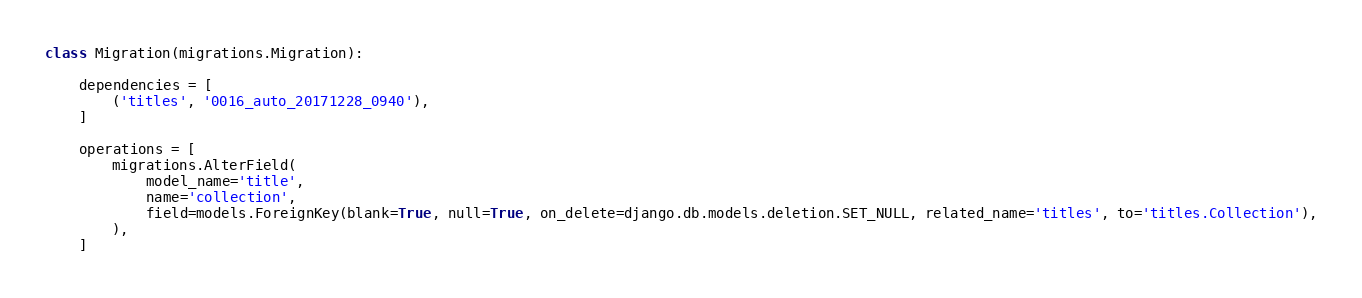Convert code to text. <code><loc_0><loc_0><loc_500><loc_500><_Python_>class Migration(migrations.Migration):

    dependencies = [
        ('titles', '0016_auto_20171228_0940'),
    ]

    operations = [
        migrations.AlterField(
            model_name='title',
            name='collection',
            field=models.ForeignKey(blank=True, null=True, on_delete=django.db.models.deletion.SET_NULL, related_name='titles', to='titles.Collection'),
        ),
    ]
</code> 